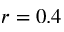Convert formula to latex. <formula><loc_0><loc_0><loc_500><loc_500>r = 0 . 4</formula> 